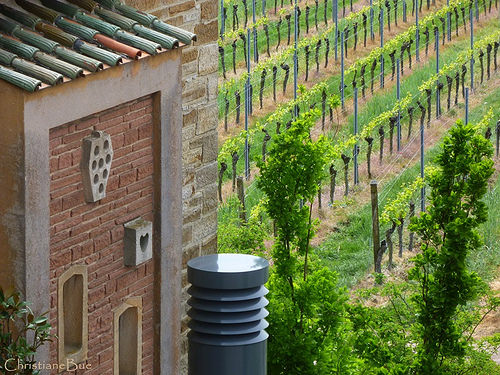<image>
Can you confirm if the vines is on the post? No. The vines is not positioned on the post. They may be near each other, but the vines is not supported by or resting on top of the post. 